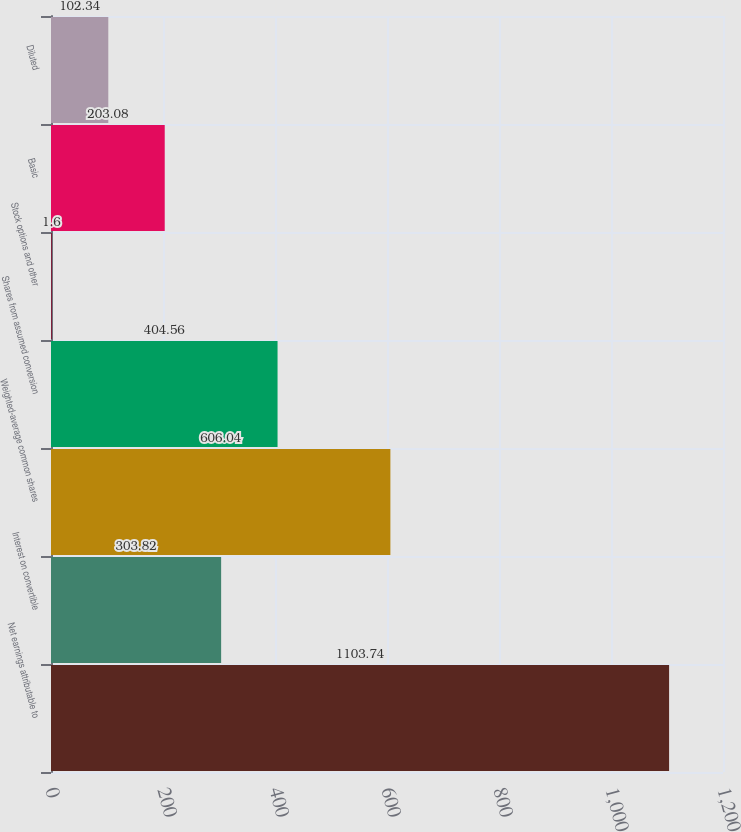Convert chart to OTSL. <chart><loc_0><loc_0><loc_500><loc_500><bar_chart><fcel>Net earnings attributable to<fcel>Interest on convertible<fcel>Weighted-average common shares<fcel>Shares from assumed conversion<fcel>Stock options and other<fcel>Basic<fcel>Diluted<nl><fcel>1103.74<fcel>303.82<fcel>606.04<fcel>404.56<fcel>1.6<fcel>203.08<fcel>102.34<nl></chart> 